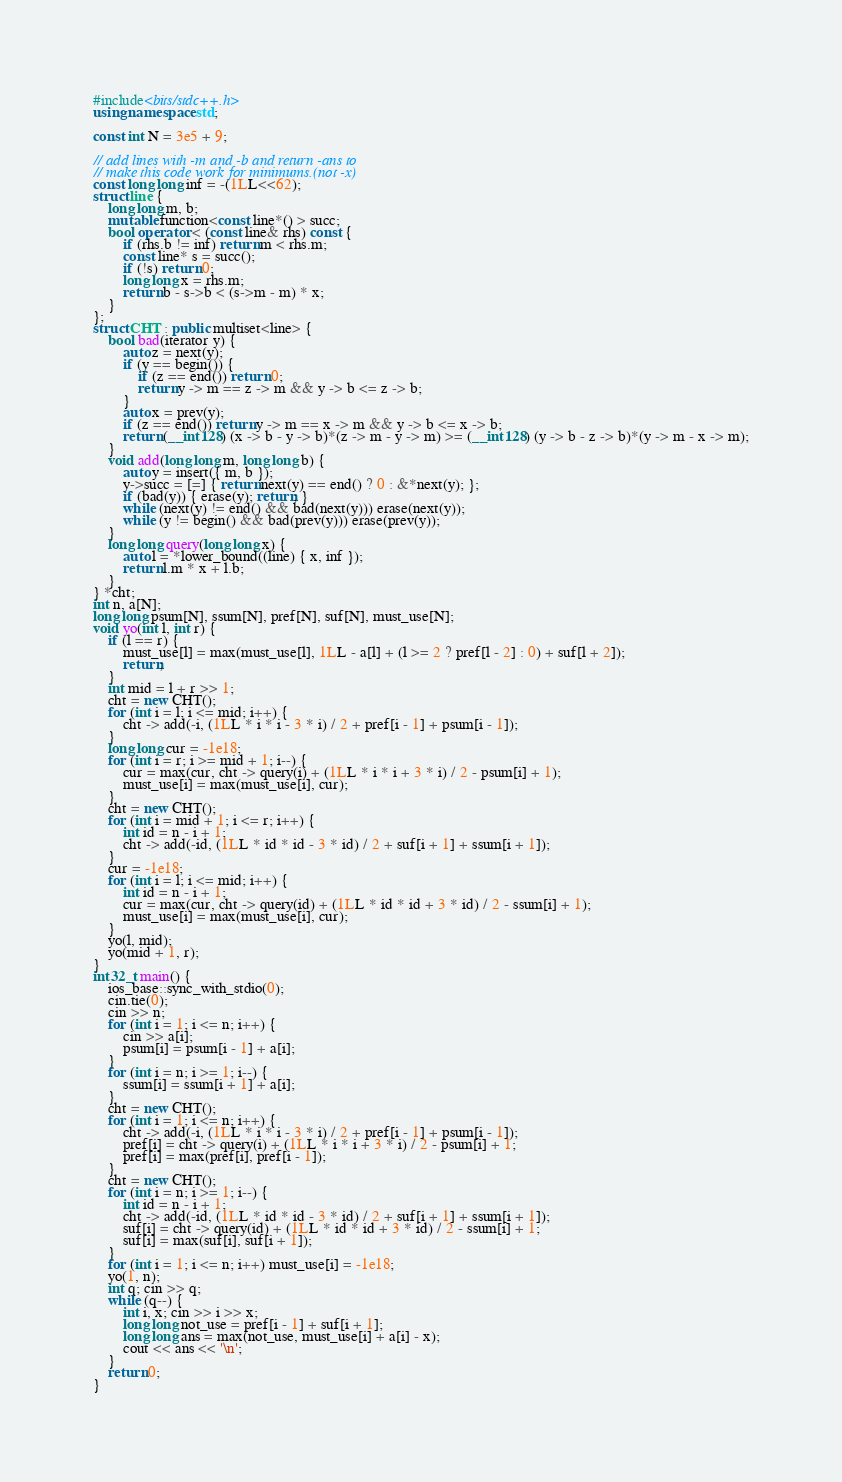Convert code to text. <code><loc_0><loc_0><loc_500><loc_500><_C++_>#include<bits/stdc++.h>
using namespace std;

const int N = 3e5 + 9;

// add lines with -m and -b and return -ans to
// make this code work for minimums.(not -x)
const long long inf = -(1LL<<62);
struct line {
    long long m, b;
    mutable function<const line*() > succ;
    bool operator < (const line& rhs) const {
        if (rhs.b != inf) return m < rhs.m;
        const line* s = succ();
        if (!s) return 0;
        long long x = rhs.m;
        return b - s->b < (s->m - m) * x;
    }
};
struct CHT : public multiset<line> {
    bool bad(iterator y) {
        auto z = next(y);
        if (y == begin()) {
            if (z == end()) return 0;
            return y -> m == z -> m && y -> b <= z -> b;
        }
        auto x = prev(y);
        if (z == end()) return y -> m == x -> m && y -> b <= x -> b;
        return (__int128) (x -> b - y -> b)*(z -> m - y -> m) >= (__int128) (y -> b - z -> b)*(y -> m - x -> m);
    }
    void add(long long m, long long b) {
        auto y = insert({ m, b });
        y->succ = [=] { return next(y) == end() ? 0 : &*next(y); };
        if (bad(y)) { erase(y); return; }
        while (next(y) != end() && bad(next(y))) erase(next(y));
        while (y != begin() && bad(prev(y))) erase(prev(y));
    }
    long long query(long long x) {
        auto l = *lower_bound((line) { x, inf });
        return l.m * x + l.b;
    }
} *cht;
int n, a[N];
long long psum[N], ssum[N], pref[N], suf[N], must_use[N];
void yo(int l, int r) {
	if (l == r) {
		must_use[l] = max(must_use[l], 1LL - a[l] + (l >= 2 ? pref[l - 2] : 0) + suf[l + 2]);
		return;
	}
	int mid = l + r >> 1;
	cht = new CHT();
	for (int i = l; i <= mid; i++) {
		cht -> add(-i, (1LL * i * i - 3 * i) / 2 + pref[i - 1] + psum[i - 1]);
	}
	long long cur = -1e18;
	for (int i = r; i >= mid + 1; i--) {
		cur = max(cur, cht -> query(i) + (1LL * i * i + 3 * i) / 2 - psum[i] + 1);
		must_use[i] = max(must_use[i], cur);
	}
	cht = new CHT();
	for (int i = mid + 1; i <= r; i++) {
		int id = n - i + 1;
		cht -> add(-id, (1LL * id * id - 3 * id) / 2 + suf[i + 1] + ssum[i + 1]);
	}
	cur = -1e18;
	for (int i = l; i <= mid; i++) {
		int id = n - i + 1;
		cur = max(cur, cht -> query(id) + (1LL * id * id + 3 * id) / 2 - ssum[i] + 1);
		must_use[i] = max(must_use[i], cur);
	}
	yo(l, mid);
	yo(mid + 1, r);
}
int32_t main() {
	ios_base::sync_with_stdio(0);
	cin.tie(0);
	cin >> n;
	for (int i = 1; i <= n; i++) {
		cin >> a[i];
		psum[i] = psum[i - 1] + a[i];
	}
	for (int i = n; i >= 1; i--) {
		ssum[i] = ssum[i + 1] + a[i];
	}
	cht = new CHT();
	for (int i = 1; i <= n; i++) {
		cht -> add(-i, (1LL * i * i - 3 * i) / 2 + pref[i - 1] + psum[i - 1]);
		pref[i] = cht -> query(i) + (1LL * i * i + 3 * i) / 2 - psum[i] + 1;
		pref[i] = max(pref[i], pref[i - 1]);
	}
	cht = new CHT();
	for (int i = n; i >= 1; i--) {
		int id = n - i + 1;
		cht -> add(-id, (1LL * id * id - 3 * id) / 2 + suf[i + 1] + ssum[i + 1]);
		suf[i] = cht -> query(id) + (1LL * id * id + 3 * id) / 2 - ssum[i] + 1;
		suf[i] = max(suf[i], suf[i + 1]);
	}
	for (int i = 1; i <= n; i++) must_use[i] = -1e18;
	yo(1, n);
	int q; cin >> q;
	while (q--) {
		int i, x; cin >> i >> x;
		long long not_use = pref[i - 1] + suf[i + 1];
		long long ans = max(not_use, must_use[i] + a[i] - x);
		cout << ans << '\n';
	}
    return 0;
}</code> 